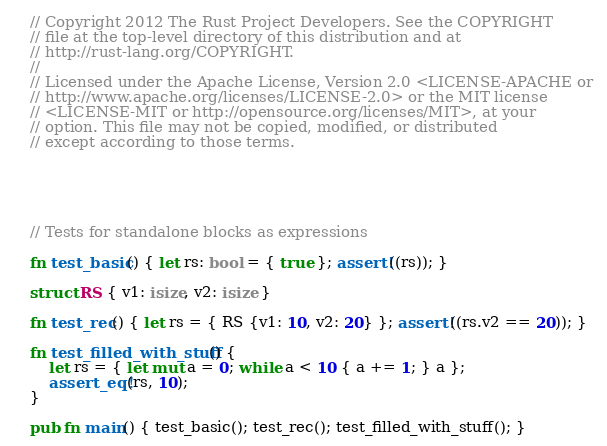Convert code to text. <code><loc_0><loc_0><loc_500><loc_500><_Rust_>// Copyright 2012 The Rust Project Developers. See the COPYRIGHT
// file at the top-level directory of this distribution and at
// http://rust-lang.org/COPYRIGHT.
//
// Licensed under the Apache License, Version 2.0 <LICENSE-APACHE or
// http://www.apache.org/licenses/LICENSE-2.0> or the MIT license
// <LICENSE-MIT or http://opensource.org/licenses/MIT>, at your
// option. This file may not be copied, modified, or distributed
// except according to those terms.





// Tests for standalone blocks as expressions

fn test_basic() { let rs: bool = { true }; assert!((rs)); }

struct RS { v1: isize, v2: isize }

fn test_rec() { let rs = { RS {v1: 10, v2: 20} }; assert!((rs.v2 == 20)); }

fn test_filled_with_stuff() {
    let rs = { let mut a = 0; while a < 10 { a += 1; } a };
    assert_eq!(rs, 10);
}

pub fn main() { test_basic(); test_rec(); test_filled_with_stuff(); }
</code> 